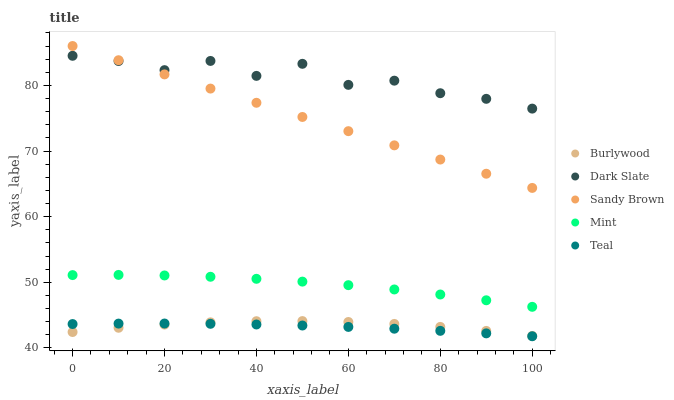Does Teal have the minimum area under the curve?
Answer yes or no. Yes. Does Dark Slate have the maximum area under the curve?
Answer yes or no. Yes. Does Sandy Brown have the minimum area under the curve?
Answer yes or no. No. Does Sandy Brown have the maximum area under the curve?
Answer yes or no. No. Is Sandy Brown the smoothest?
Answer yes or no. Yes. Is Dark Slate the roughest?
Answer yes or no. Yes. Is Dark Slate the smoothest?
Answer yes or no. No. Is Sandy Brown the roughest?
Answer yes or no. No. Does Teal have the lowest value?
Answer yes or no. Yes. Does Sandy Brown have the lowest value?
Answer yes or no. No. Does Sandy Brown have the highest value?
Answer yes or no. Yes. Does Dark Slate have the highest value?
Answer yes or no. No. Is Burlywood less than Dark Slate?
Answer yes or no. Yes. Is Mint greater than Burlywood?
Answer yes or no. Yes. Does Dark Slate intersect Sandy Brown?
Answer yes or no. Yes. Is Dark Slate less than Sandy Brown?
Answer yes or no. No. Is Dark Slate greater than Sandy Brown?
Answer yes or no. No. Does Burlywood intersect Dark Slate?
Answer yes or no. No. 